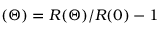Convert formula to latex. <formula><loc_0><loc_0><loc_500><loc_500>( \Theta ) = R ( \Theta ) / R ( 0 ) - 1</formula> 